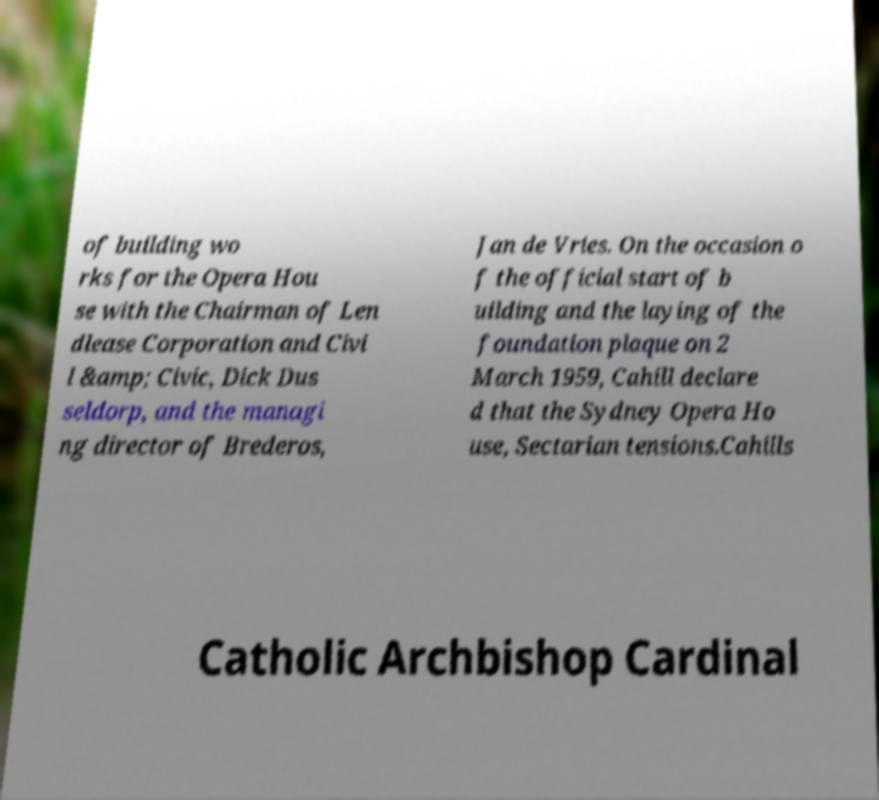Please identify and transcribe the text found in this image. of building wo rks for the Opera Hou se with the Chairman of Len dlease Corporation and Civi l &amp; Civic, Dick Dus seldorp, and the managi ng director of Brederos, Jan de Vries. On the occasion o f the official start of b uilding and the laying of the foundation plaque on 2 March 1959, Cahill declare d that the Sydney Opera Ho use, Sectarian tensions.Cahills Catholic Archbishop Cardinal 